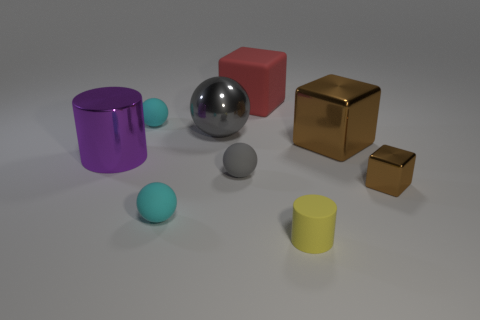Is there any other thing that is the same size as the yellow cylinder?
Your answer should be compact. Yes. What size is the matte thing that is in front of the tiny brown metallic cube and behind the yellow rubber cylinder?
Provide a short and direct response. Small. How many other shiny objects are the same size as the gray metallic object?
Make the answer very short. 2. What number of brown metal objects are on the left side of the cylinder that is on the left side of the small yellow matte thing?
Your answer should be very brief. 0. There is a matte sphere that is in front of the tiny block; is it the same color as the big rubber block?
Your answer should be compact. No. Is there a yellow rubber object that is behind the thing that is on the right side of the shiny block that is left of the small block?
Your response must be concise. No. What shape is the object that is both behind the big purple object and right of the yellow rubber cylinder?
Your response must be concise. Cube. Are there any tiny matte cylinders that have the same color as the matte cube?
Offer a very short reply. No. What is the color of the cylinder that is on the right side of the cylinder left of the red matte block?
Provide a succinct answer. Yellow. There is a cyan ball in front of the tiny cyan ball that is behind the tiny cyan object in front of the big metal cube; what size is it?
Your answer should be very brief. Small. 